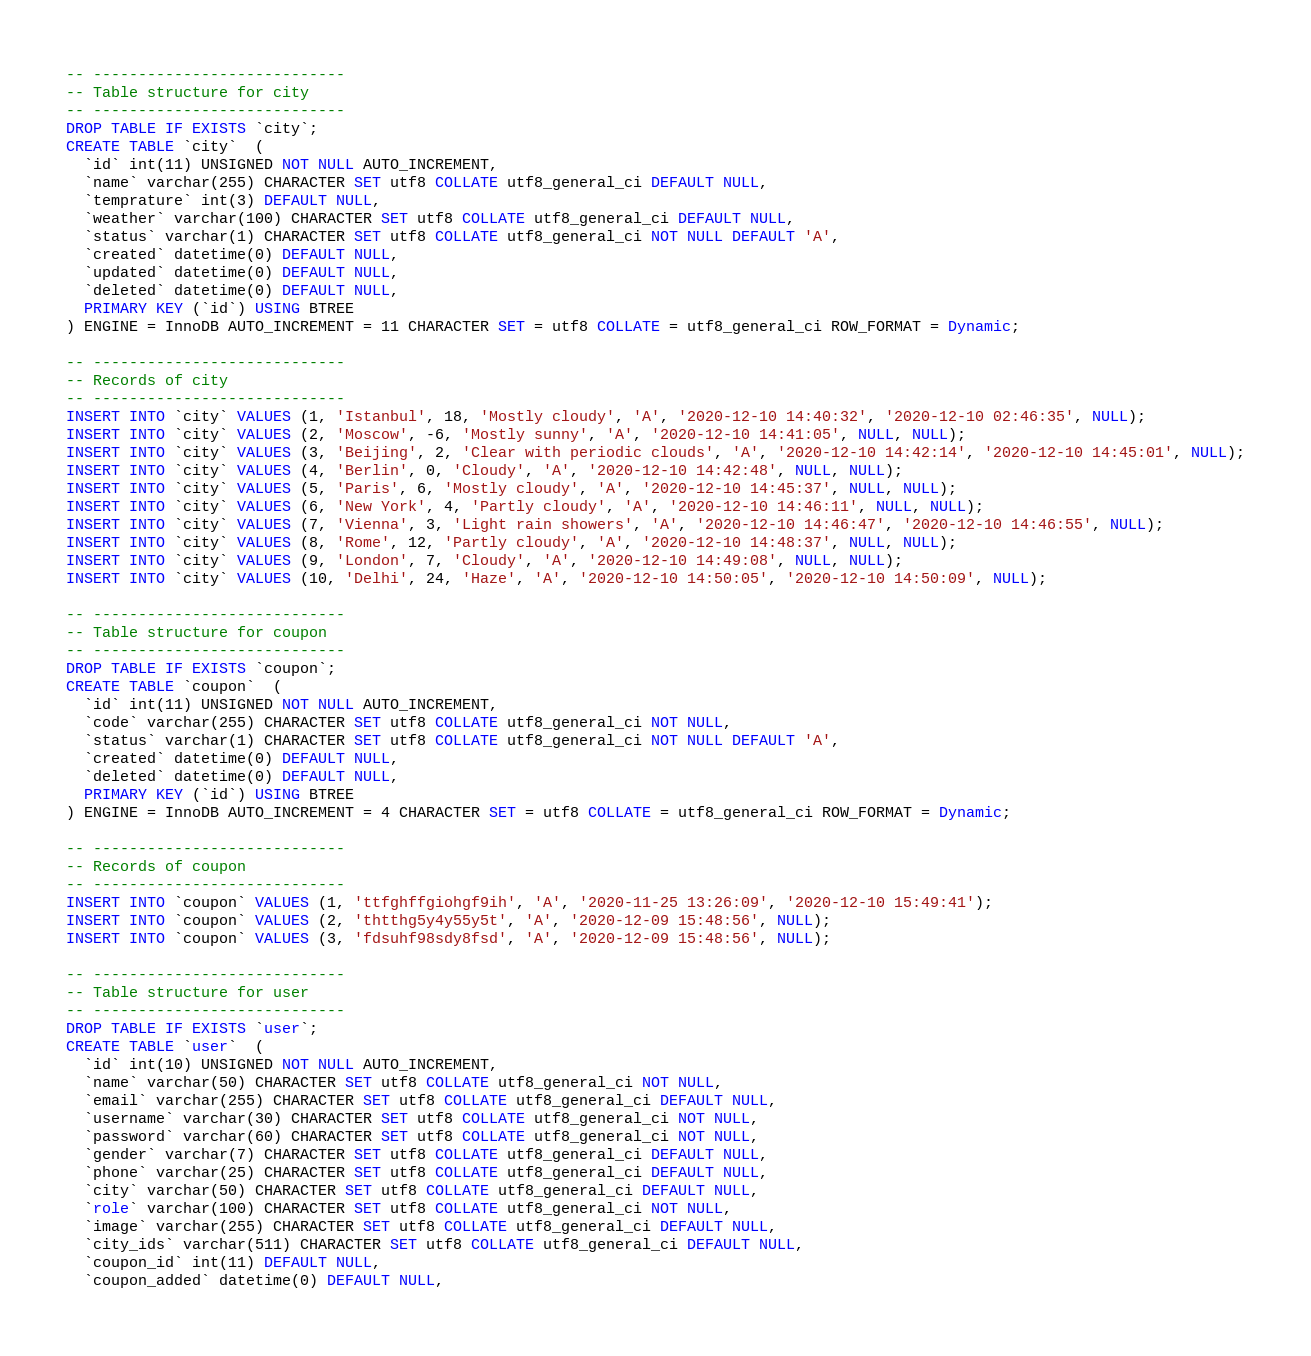<code> <loc_0><loc_0><loc_500><loc_500><_SQL_>
-- ----------------------------
-- Table structure for city
-- ----------------------------
DROP TABLE IF EXISTS `city`;
CREATE TABLE `city`  (
  `id` int(11) UNSIGNED NOT NULL AUTO_INCREMENT,
  `name` varchar(255) CHARACTER SET utf8 COLLATE utf8_general_ci DEFAULT NULL,
  `temprature` int(3) DEFAULT NULL,
  `weather` varchar(100) CHARACTER SET utf8 COLLATE utf8_general_ci DEFAULT NULL,
  `status` varchar(1) CHARACTER SET utf8 COLLATE utf8_general_ci NOT NULL DEFAULT 'A',
  `created` datetime(0) DEFAULT NULL,
  `updated` datetime(0) DEFAULT NULL,
  `deleted` datetime(0) DEFAULT NULL,
  PRIMARY KEY (`id`) USING BTREE
) ENGINE = InnoDB AUTO_INCREMENT = 11 CHARACTER SET = utf8 COLLATE = utf8_general_ci ROW_FORMAT = Dynamic;

-- ----------------------------
-- Records of city
-- ----------------------------
INSERT INTO `city` VALUES (1, 'Istanbul', 18, 'Mostly cloudy', 'A', '2020-12-10 14:40:32', '2020-12-10 02:46:35', NULL);
INSERT INTO `city` VALUES (2, 'Moscow', -6, 'Mostly sunny', 'A', '2020-12-10 14:41:05', NULL, NULL);
INSERT INTO `city` VALUES (3, 'Beijing', 2, 'Clear with periodic clouds', 'A', '2020-12-10 14:42:14', '2020-12-10 14:45:01', NULL);
INSERT INTO `city` VALUES (4, 'Berlin', 0, 'Cloudy', 'A', '2020-12-10 14:42:48', NULL, NULL);
INSERT INTO `city` VALUES (5, 'Paris', 6, 'Mostly cloudy', 'A', '2020-12-10 14:45:37', NULL, NULL);
INSERT INTO `city` VALUES (6, 'New York', 4, 'Partly cloudy', 'A', '2020-12-10 14:46:11', NULL, NULL);
INSERT INTO `city` VALUES (7, 'Vienna', 3, 'Light rain showers', 'A', '2020-12-10 14:46:47', '2020-12-10 14:46:55', NULL);
INSERT INTO `city` VALUES (8, 'Rome', 12, 'Partly cloudy', 'A', '2020-12-10 14:48:37', NULL, NULL);
INSERT INTO `city` VALUES (9, 'London', 7, 'Cloudy', 'A', '2020-12-10 14:49:08', NULL, NULL);
INSERT INTO `city` VALUES (10, 'Delhi', 24, 'Haze', 'A', '2020-12-10 14:50:05', '2020-12-10 14:50:09', NULL);

-- ----------------------------
-- Table structure for coupon
-- ----------------------------
DROP TABLE IF EXISTS `coupon`;
CREATE TABLE `coupon`  (
  `id` int(11) UNSIGNED NOT NULL AUTO_INCREMENT,
  `code` varchar(255) CHARACTER SET utf8 COLLATE utf8_general_ci NOT NULL,
  `status` varchar(1) CHARACTER SET utf8 COLLATE utf8_general_ci NOT NULL DEFAULT 'A',
  `created` datetime(0) DEFAULT NULL,
  `deleted` datetime(0) DEFAULT NULL,
  PRIMARY KEY (`id`) USING BTREE
) ENGINE = InnoDB AUTO_INCREMENT = 4 CHARACTER SET = utf8 COLLATE = utf8_general_ci ROW_FORMAT = Dynamic;

-- ----------------------------
-- Records of coupon
-- ----------------------------
INSERT INTO `coupon` VALUES (1, 'ttfghffgiohgf9ih', 'A', '2020-11-25 13:26:09', '2020-12-10 15:49:41');
INSERT INTO `coupon` VALUES (2, 'thtthg5y4y55y5t', 'A', '2020-12-09 15:48:56', NULL);
INSERT INTO `coupon` VALUES (3, 'fdsuhf98sdy8fsd', 'A', '2020-12-09 15:48:56', NULL);

-- ----------------------------
-- Table structure for user
-- ----------------------------
DROP TABLE IF EXISTS `user`;
CREATE TABLE `user`  (
  `id` int(10) UNSIGNED NOT NULL AUTO_INCREMENT,
  `name` varchar(50) CHARACTER SET utf8 COLLATE utf8_general_ci NOT NULL,
  `email` varchar(255) CHARACTER SET utf8 COLLATE utf8_general_ci DEFAULT NULL,
  `username` varchar(30) CHARACTER SET utf8 COLLATE utf8_general_ci NOT NULL,
  `password` varchar(60) CHARACTER SET utf8 COLLATE utf8_general_ci NOT NULL,
  `gender` varchar(7) CHARACTER SET utf8 COLLATE utf8_general_ci DEFAULT NULL,
  `phone` varchar(25) CHARACTER SET utf8 COLLATE utf8_general_ci DEFAULT NULL,
  `city` varchar(50) CHARACTER SET utf8 COLLATE utf8_general_ci DEFAULT NULL,
  `role` varchar(100) CHARACTER SET utf8 COLLATE utf8_general_ci NOT NULL,
  `image` varchar(255) CHARACTER SET utf8 COLLATE utf8_general_ci DEFAULT NULL,
  `city_ids` varchar(511) CHARACTER SET utf8 COLLATE utf8_general_ci DEFAULT NULL,
  `coupon_id` int(11) DEFAULT NULL,
  `coupon_added` datetime(0) DEFAULT NULL,</code> 